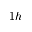Convert formula to latex. <formula><loc_0><loc_0><loc_500><loc_500>1 h</formula> 